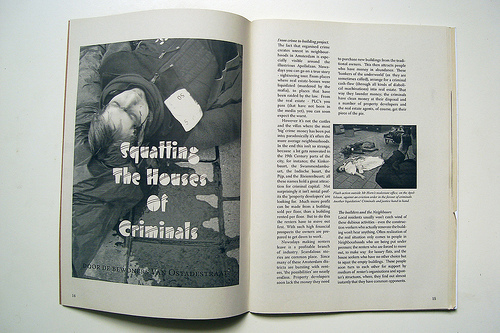<image>
Can you confirm if the table is under the magazine? Yes. The table is positioned underneath the magazine, with the magazine above it in the vertical space. 